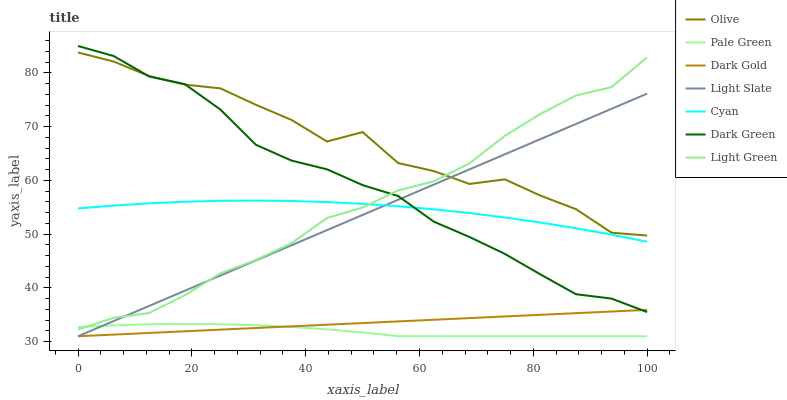Does Pale Green have the minimum area under the curve?
Answer yes or no. Yes. Does Olive have the maximum area under the curve?
Answer yes or no. Yes. Does Light Slate have the minimum area under the curve?
Answer yes or no. No. Does Light Slate have the maximum area under the curve?
Answer yes or no. No. Is Dark Gold the smoothest?
Answer yes or no. Yes. Is Olive the roughest?
Answer yes or no. Yes. Is Light Slate the smoothest?
Answer yes or no. No. Is Light Slate the roughest?
Answer yes or no. No. Does Dark Gold have the lowest value?
Answer yes or no. Yes. Does Light Green have the lowest value?
Answer yes or no. No. Does Dark Green have the highest value?
Answer yes or no. Yes. Does Light Slate have the highest value?
Answer yes or no. No. Is Pale Green less than Cyan?
Answer yes or no. Yes. Is Cyan greater than Dark Gold?
Answer yes or no. Yes. Does Cyan intersect Light Slate?
Answer yes or no. Yes. Is Cyan less than Light Slate?
Answer yes or no. No. Is Cyan greater than Light Slate?
Answer yes or no. No. Does Pale Green intersect Cyan?
Answer yes or no. No. 